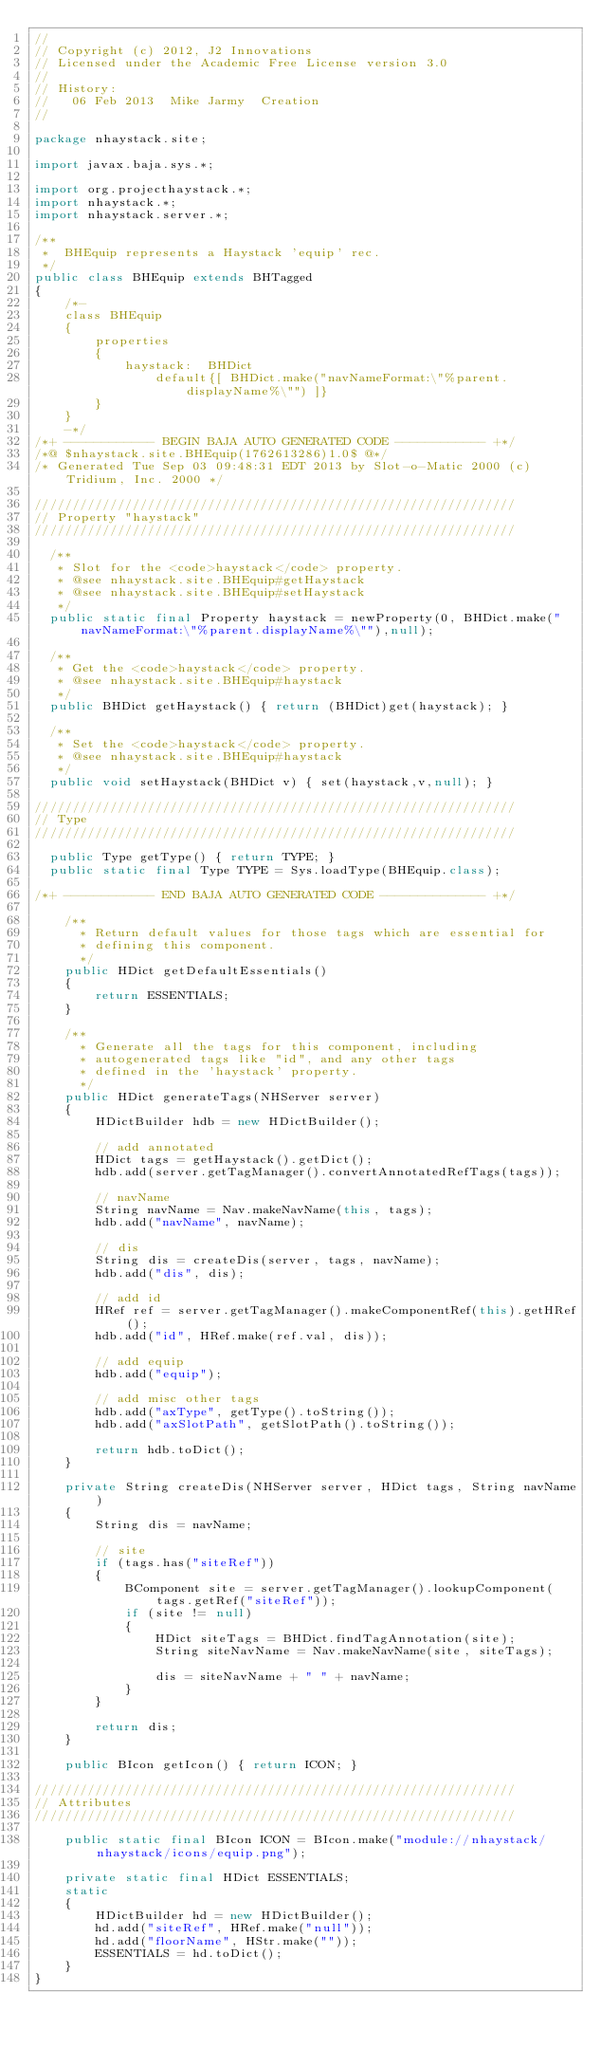<code> <loc_0><loc_0><loc_500><loc_500><_Java_>//
// Copyright (c) 2012, J2 Innovations
// Licensed under the Academic Free License version 3.0
//
// History:
//   06 Feb 2013  Mike Jarmy  Creation
//

package nhaystack.site;

import javax.baja.sys.*;

import org.projecthaystack.*;
import nhaystack.*;
import nhaystack.server.*;

/**
 *  BHEquip represents a Haystack 'equip' rec.
 */
public class BHEquip extends BHTagged
{
    /*-
    class BHEquip
    {
        properties
        {
            haystack:  BHDict 
                default{[ BHDict.make("navNameFormat:\"%parent.displayName%\"") ]}
        }
    }
    -*/
/*+ ------------ BEGIN BAJA AUTO GENERATED CODE ------------ +*/
/*@ $nhaystack.site.BHEquip(1762613286)1.0$ @*/
/* Generated Tue Sep 03 09:48:31 EDT 2013 by Slot-o-Matic 2000 (c) Tridium, Inc. 2000 */

////////////////////////////////////////////////////////////////
// Property "haystack"
////////////////////////////////////////////////////////////////
  
  /**
   * Slot for the <code>haystack</code> property.
   * @see nhaystack.site.BHEquip#getHaystack
   * @see nhaystack.site.BHEquip#setHaystack
   */
  public static final Property haystack = newProperty(0, BHDict.make("navNameFormat:\"%parent.displayName%\""),null);
  
  /**
   * Get the <code>haystack</code> property.
   * @see nhaystack.site.BHEquip#haystack
   */
  public BHDict getHaystack() { return (BHDict)get(haystack); }
  
  /**
   * Set the <code>haystack</code> property.
   * @see nhaystack.site.BHEquip#haystack
   */
  public void setHaystack(BHDict v) { set(haystack,v,null); }

////////////////////////////////////////////////////////////////
// Type
////////////////////////////////////////////////////////////////
  
  public Type getType() { return TYPE; }
  public static final Type TYPE = Sys.loadType(BHEquip.class);

/*+ ------------ END BAJA AUTO GENERATED CODE -------------- +*/

    /**
      * Return default values for those tags which are essential for
      * defining this component.
      */
    public HDict getDefaultEssentials()
    {
        return ESSENTIALS;
    }
  
    /**
      * Generate all the tags for this component, including
      * autogenerated tags like "id", and any other tags 
      * defined in the 'haystack' property.
      */
    public HDict generateTags(NHServer server)
    {
        HDictBuilder hdb = new HDictBuilder();

        // add annotated
        HDict tags = getHaystack().getDict();
        hdb.add(server.getTagManager().convertAnnotatedRefTags(tags));

        // navName
        String navName = Nav.makeNavName(this, tags);
        hdb.add("navName", navName);

        // dis
        String dis = createDis(server, tags, navName);
        hdb.add("dis", dis);

        // add id
        HRef ref = server.getTagManager().makeComponentRef(this).getHRef();
        hdb.add("id", HRef.make(ref.val, dis));

        // add equip
        hdb.add("equip");

        // add misc other tags
        hdb.add("axType", getType().toString());
        hdb.add("axSlotPath", getSlotPath().toString());

        return hdb.toDict();
    }

    private String createDis(NHServer server, HDict tags, String navName)
    {
        String dis = navName;

        // site
        if (tags.has("siteRef"))
        {
            BComponent site = server.getTagManager().lookupComponent(tags.getRef("siteRef"));
            if (site != null)
            {
                HDict siteTags = BHDict.findTagAnnotation(site);
                String siteNavName = Nav.makeNavName(site, siteTags);

                dis = siteNavName + " " + navName;
            }
        }

        return dis;
    }

    public BIcon getIcon() { return ICON; }

////////////////////////////////////////////////////////////////
// Attributes
////////////////////////////////////////////////////////////////

    public static final BIcon ICON = BIcon.make("module://nhaystack/nhaystack/icons/equip.png");

    private static final HDict ESSENTIALS;
    static
    {
        HDictBuilder hd = new HDictBuilder();
        hd.add("siteRef", HRef.make("null"));
        hd.add("floorName", HStr.make(""));
        ESSENTIALS = hd.toDict();
    }
}

</code> 